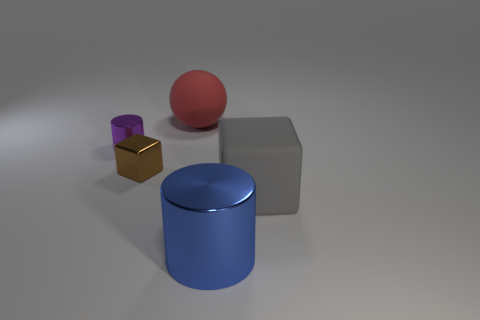Add 5 blue matte things. How many objects exist? 10 Subtract all purple cylinders. How many cylinders are left? 1 Subtract 1 cylinders. How many cylinders are left? 1 Subtract all cubes. How many objects are left? 3 Subtract all green cubes. How many purple cylinders are left? 1 Add 3 matte balls. How many matte balls exist? 4 Subtract 0 green spheres. How many objects are left? 5 Subtract all blue balls. Subtract all red cylinders. How many balls are left? 1 Subtract all small green rubber balls. Subtract all tiny metallic things. How many objects are left? 3 Add 5 purple cylinders. How many purple cylinders are left? 6 